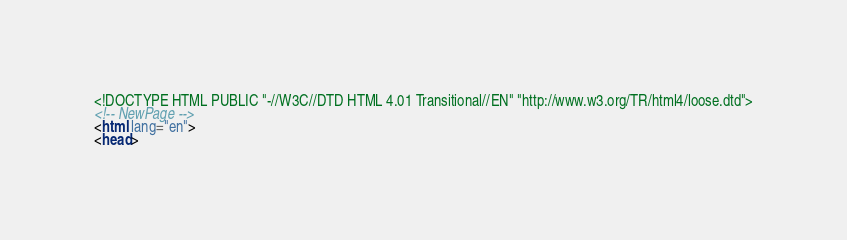<code> <loc_0><loc_0><loc_500><loc_500><_HTML_><!DOCTYPE HTML PUBLIC "-//W3C//DTD HTML 4.01 Transitional//EN" "http://www.w3.org/TR/html4/loose.dtd">
<!-- NewPage -->
<html lang="en">
<head></code> 